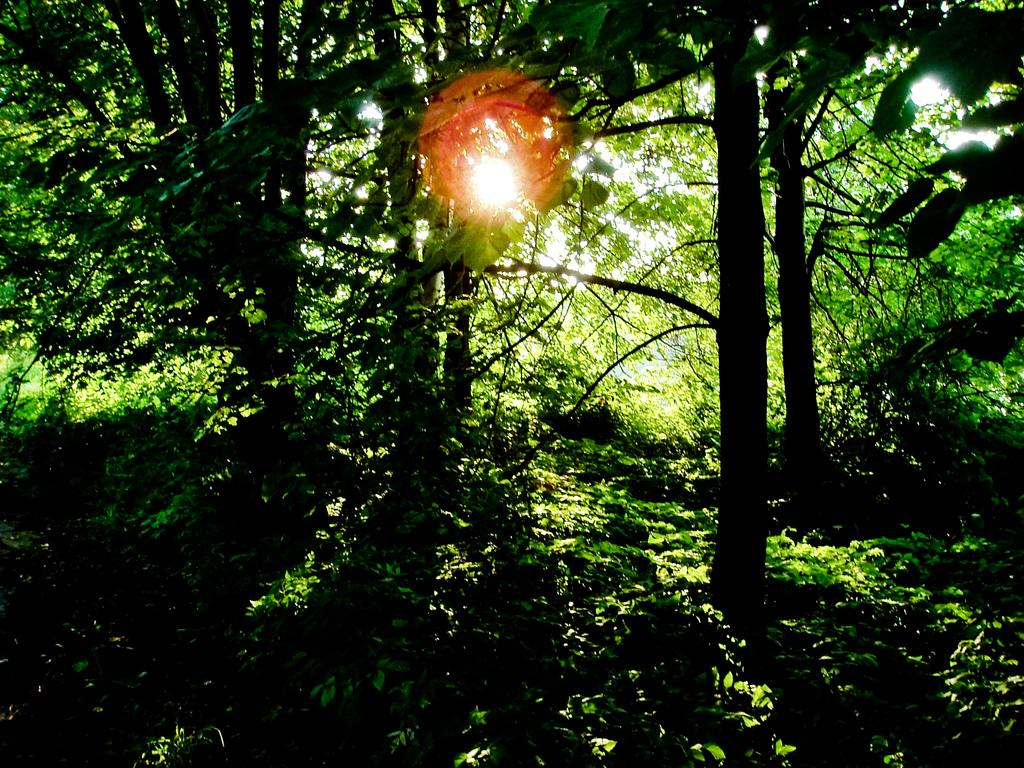What type of vegetation can be seen in the image? There are plants and trees in the image. Can you describe the background of the image? The sun is visible in the background of the image. What type of bread can be seen in the image? There is no bread present in the image; it features plants, trees, and the sun. 